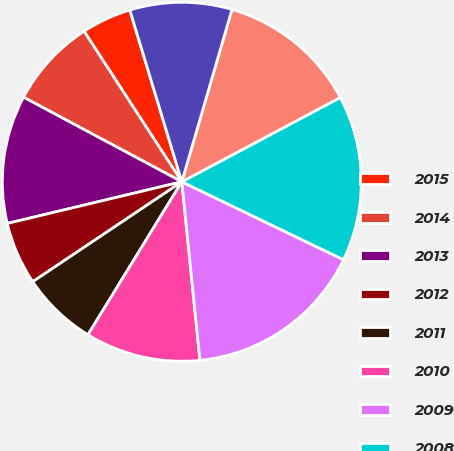Convert chart to OTSL. <chart><loc_0><loc_0><loc_500><loc_500><pie_chart><fcel>2015<fcel>2014<fcel>2013<fcel>2012<fcel>2011<fcel>2010<fcel>2009<fcel>2008<fcel>2007<fcel>2006<nl><fcel>4.49%<fcel>8.02%<fcel>11.54%<fcel>5.67%<fcel>6.84%<fcel>10.37%<fcel>16.24%<fcel>14.93%<fcel>12.71%<fcel>9.19%<nl></chart> 